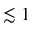Convert formula to latex. <formula><loc_0><loc_0><loc_500><loc_500>\lesssim 1</formula> 